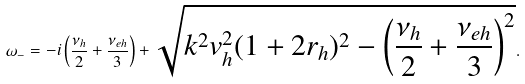Convert formula to latex. <formula><loc_0><loc_0><loc_500><loc_500>\omega _ { - } = - i \left ( \frac { \nu _ { h } } { 2 } + \frac { \nu _ { e h } } { 3 } \right ) + \sqrt { { { k } ^ { 2 } } v _ { h } ^ { 2 } ( 1 + 2 r _ { h } ) ^ { 2 } - \left ( \frac { \nu _ { h } } { 2 } + \frac { \nu _ { e h } } { 3 } \right ) ^ { 2 } } .</formula> 